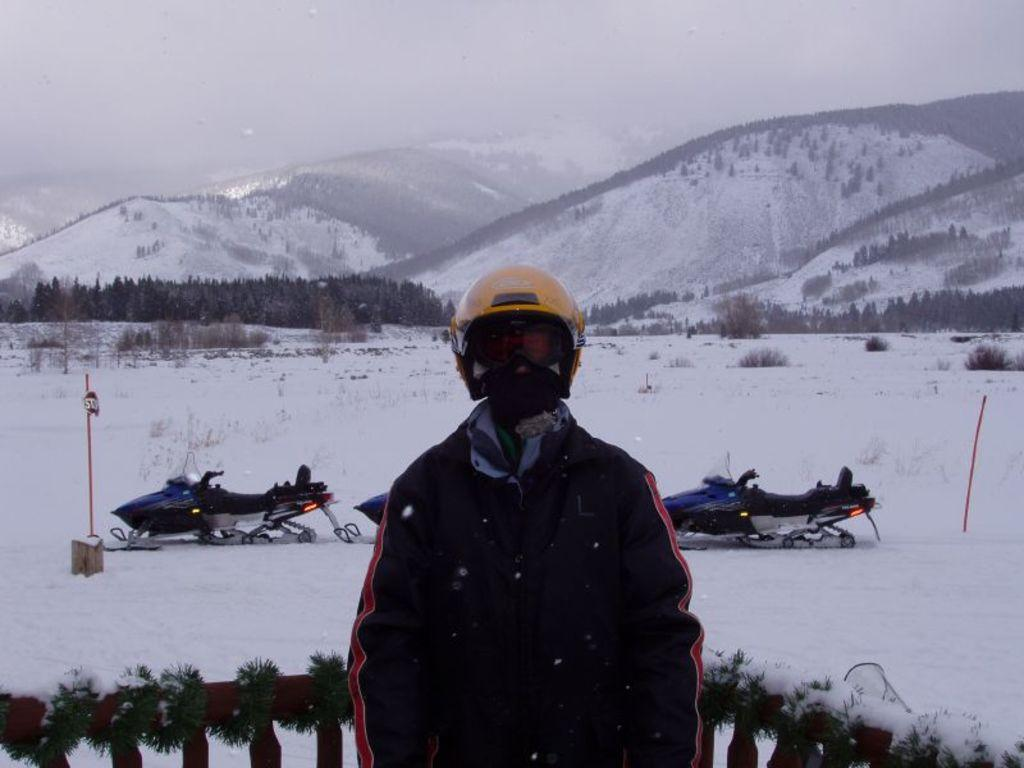What is the main subject of the image? There is a person standing in the image. Can you describe the person's attire? The person is wearing clothes and a helmet. What else can be seen in the image besides the person? There are vehicles, a fence, snow, trees, poles, mountains, and fog visible in the image. What might the person be doing in the image? The presence of a helmet and vehicles suggests that the person might be engaged in an outdoor activity, such as skiing or snowboarding. How does the environment in the image appear? The image features snow, trees, mountains, and fog, which suggests a cold, wintery setting. What type of music can be heard playing in the background of the image? There is no indication of music or sound in the image, so it cannot be determined from the image alone. 